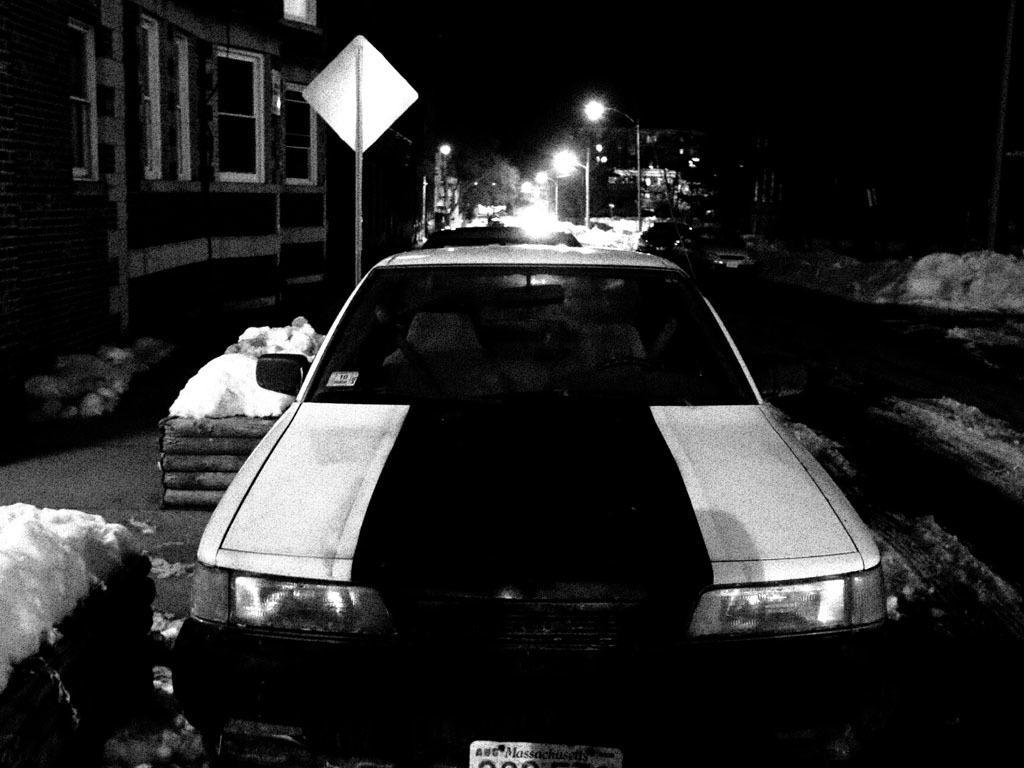How would you summarize this image in a sentence or two? This is a black and white image. In the center there is a car parked on the ground. On the left there are some objects placed on the ground. In the background you we can see the street lights, poles, buildings and a board. 